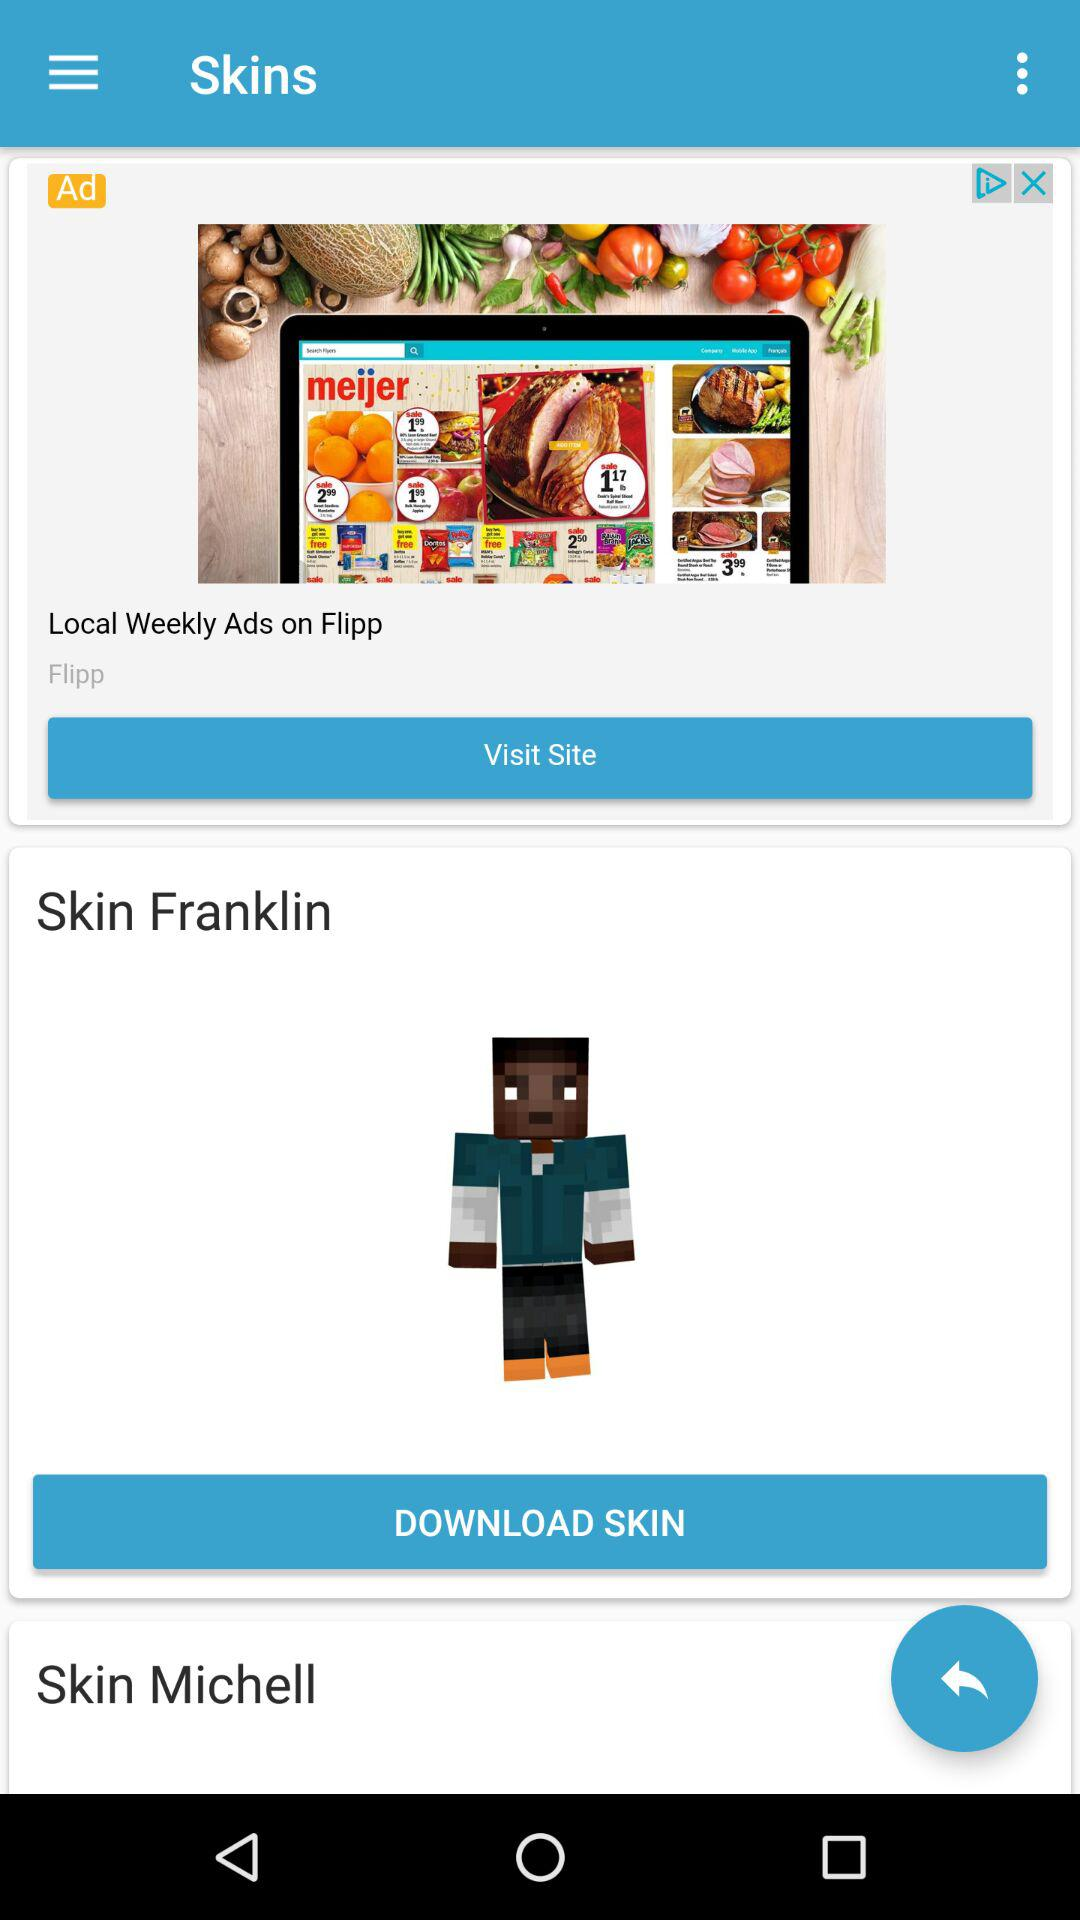What is the name of the "Skin" available for download? The name of the "Skin" available for download is "Skin Franklin". 